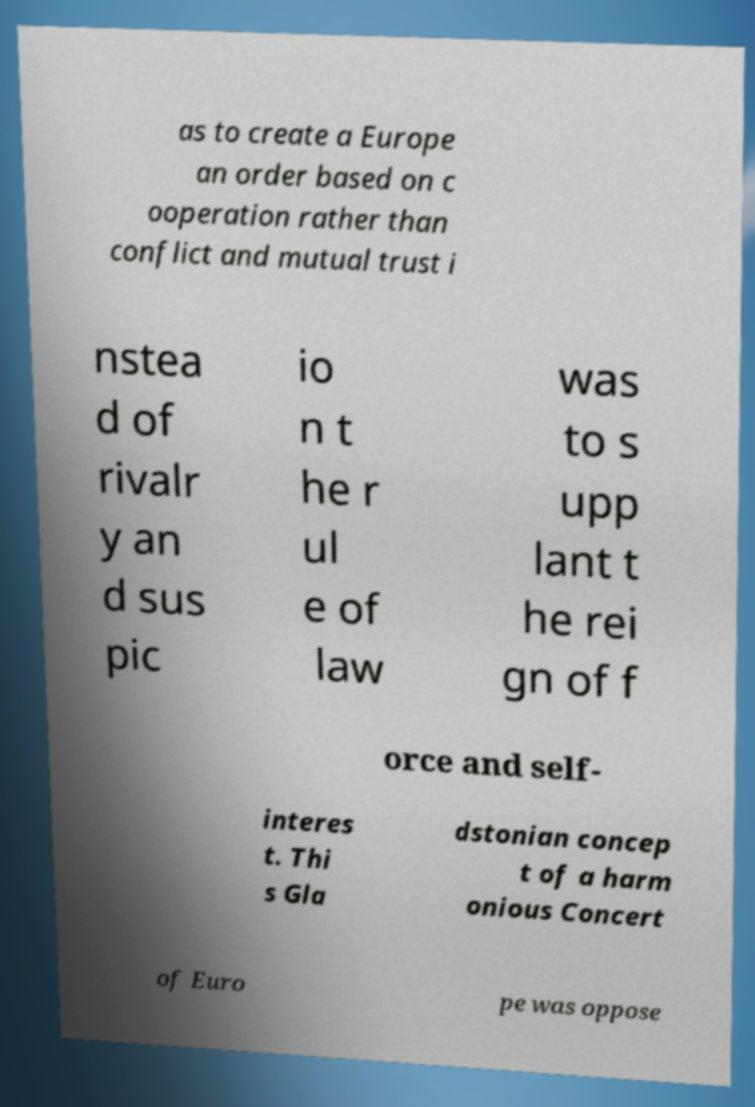Please read and relay the text visible in this image. What does it say? as to create a Europe an order based on c ooperation rather than conflict and mutual trust i nstea d of rivalr y an d sus pic io n t he r ul e of law was to s upp lant t he rei gn of f orce and self- interes t. Thi s Gla dstonian concep t of a harm onious Concert of Euro pe was oppose 